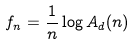<formula> <loc_0><loc_0><loc_500><loc_500>f _ { n } = \frac { 1 } { n } \log A _ { d } ( n )</formula> 